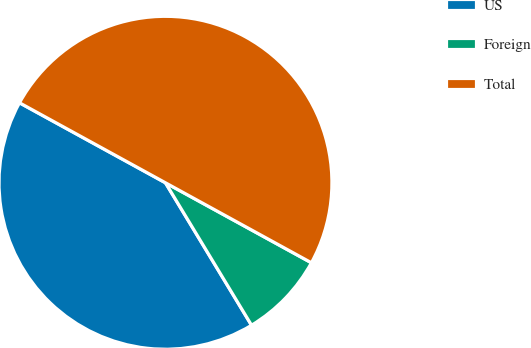Convert chart to OTSL. <chart><loc_0><loc_0><loc_500><loc_500><pie_chart><fcel>US<fcel>Foreign<fcel>Total<nl><fcel>41.63%<fcel>8.37%<fcel>50.0%<nl></chart> 